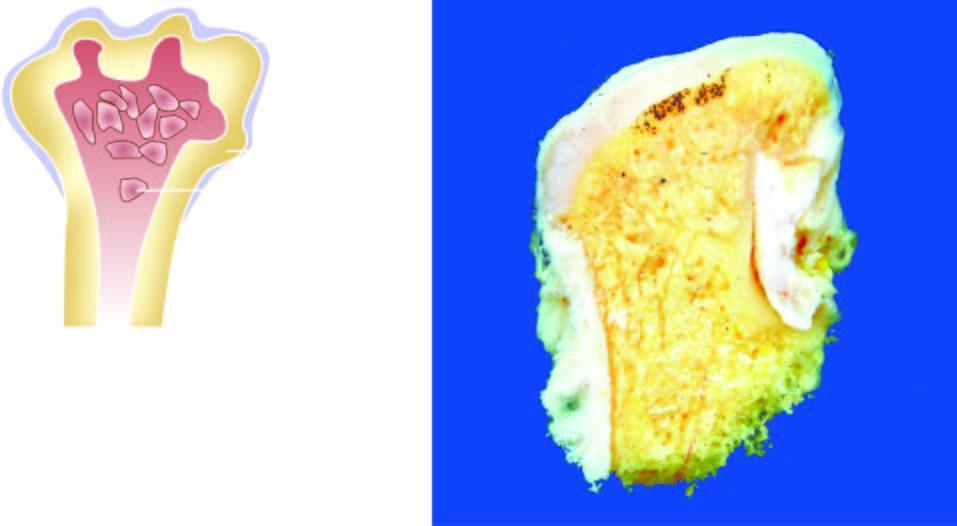what do these nodules have?
Answer the question using a single word or phrase. Cartilaginous caps and inner osseous tissue 